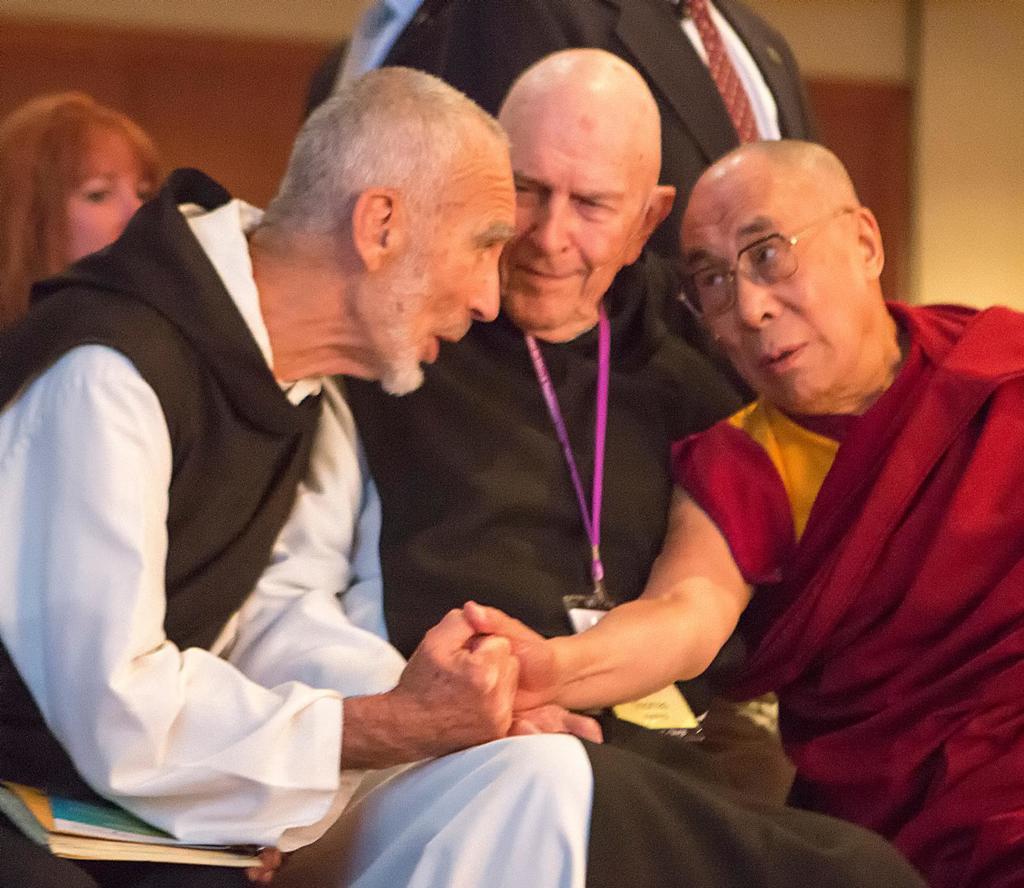Can you describe this image briefly? In the image there are few people and three men were sitting in the front,the first person and last person are talking to each other and the first person is holding some book in his hand. Behind these three people there is another man and he is standing and he is wearing a blazer and the background of these people is blur. 